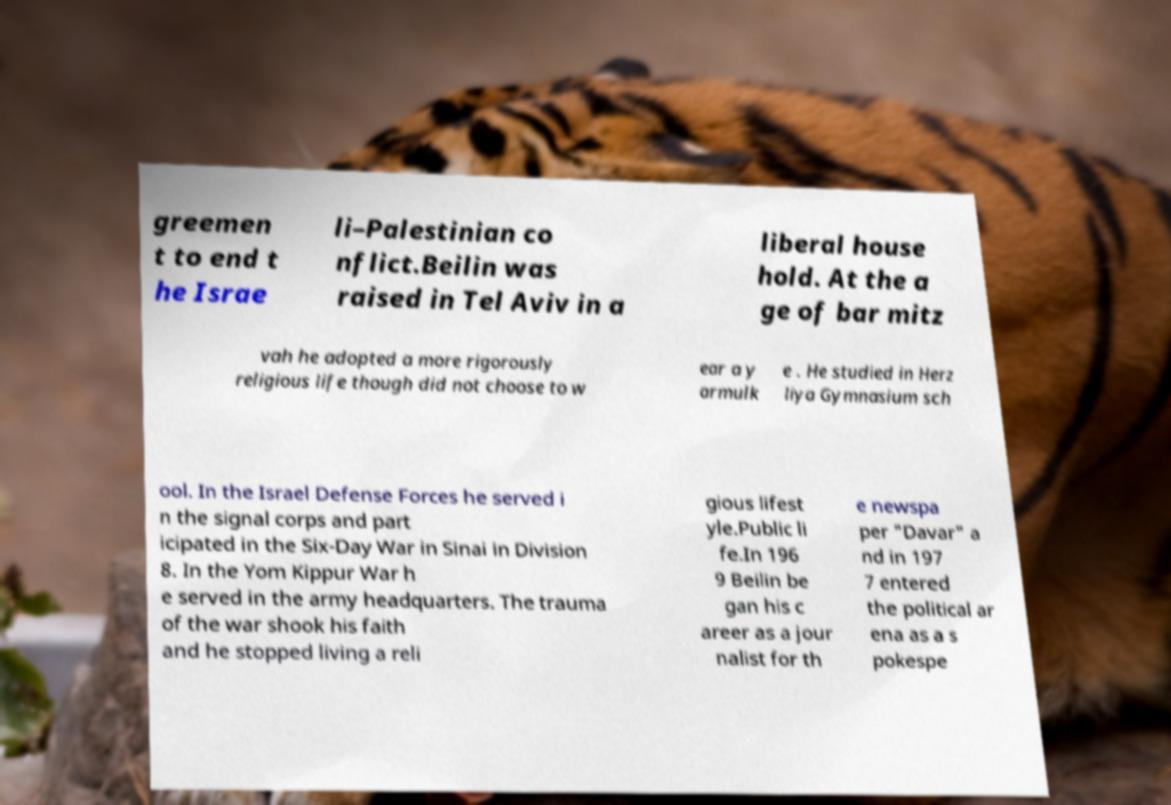There's text embedded in this image that I need extracted. Can you transcribe it verbatim? greemen t to end t he Israe li–Palestinian co nflict.Beilin was raised in Tel Aviv in a liberal house hold. At the a ge of bar mitz vah he adopted a more rigorously religious life though did not choose to w ear a y armulk e . He studied in Herz liya Gymnasium sch ool. In the Israel Defense Forces he served i n the signal corps and part icipated in the Six-Day War in Sinai in Division 8. In the Yom Kippur War h e served in the army headquarters. The trauma of the war shook his faith and he stopped living a reli gious lifest yle.Public li fe.In 196 9 Beilin be gan his c areer as a jour nalist for th e newspa per "Davar" a nd in 197 7 entered the political ar ena as a s pokespe 